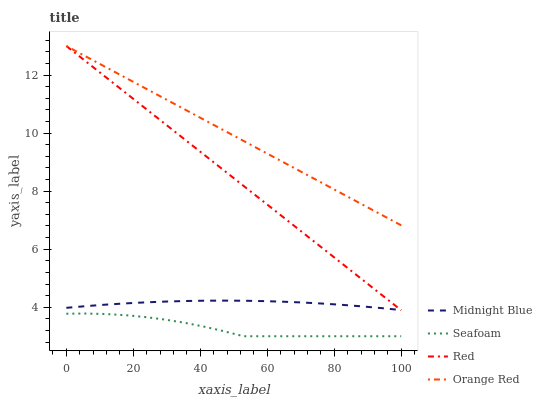Does Seafoam have the minimum area under the curve?
Answer yes or no. Yes. Does Orange Red have the maximum area under the curve?
Answer yes or no. Yes. Does Midnight Blue have the minimum area under the curve?
Answer yes or no. No. Does Midnight Blue have the maximum area under the curve?
Answer yes or no. No. Is Orange Red the smoothest?
Answer yes or no. Yes. Is Seafoam the roughest?
Answer yes or no. Yes. Is Midnight Blue the smoothest?
Answer yes or no. No. Is Midnight Blue the roughest?
Answer yes or no. No. Does Seafoam have the lowest value?
Answer yes or no. Yes. Does Midnight Blue have the lowest value?
Answer yes or no. No. Does Red have the highest value?
Answer yes or no. Yes. Does Midnight Blue have the highest value?
Answer yes or no. No. Is Seafoam less than Orange Red?
Answer yes or no. Yes. Is Red greater than Seafoam?
Answer yes or no. Yes. Does Red intersect Midnight Blue?
Answer yes or no. Yes. Is Red less than Midnight Blue?
Answer yes or no. No. Is Red greater than Midnight Blue?
Answer yes or no. No. Does Seafoam intersect Orange Red?
Answer yes or no. No. 